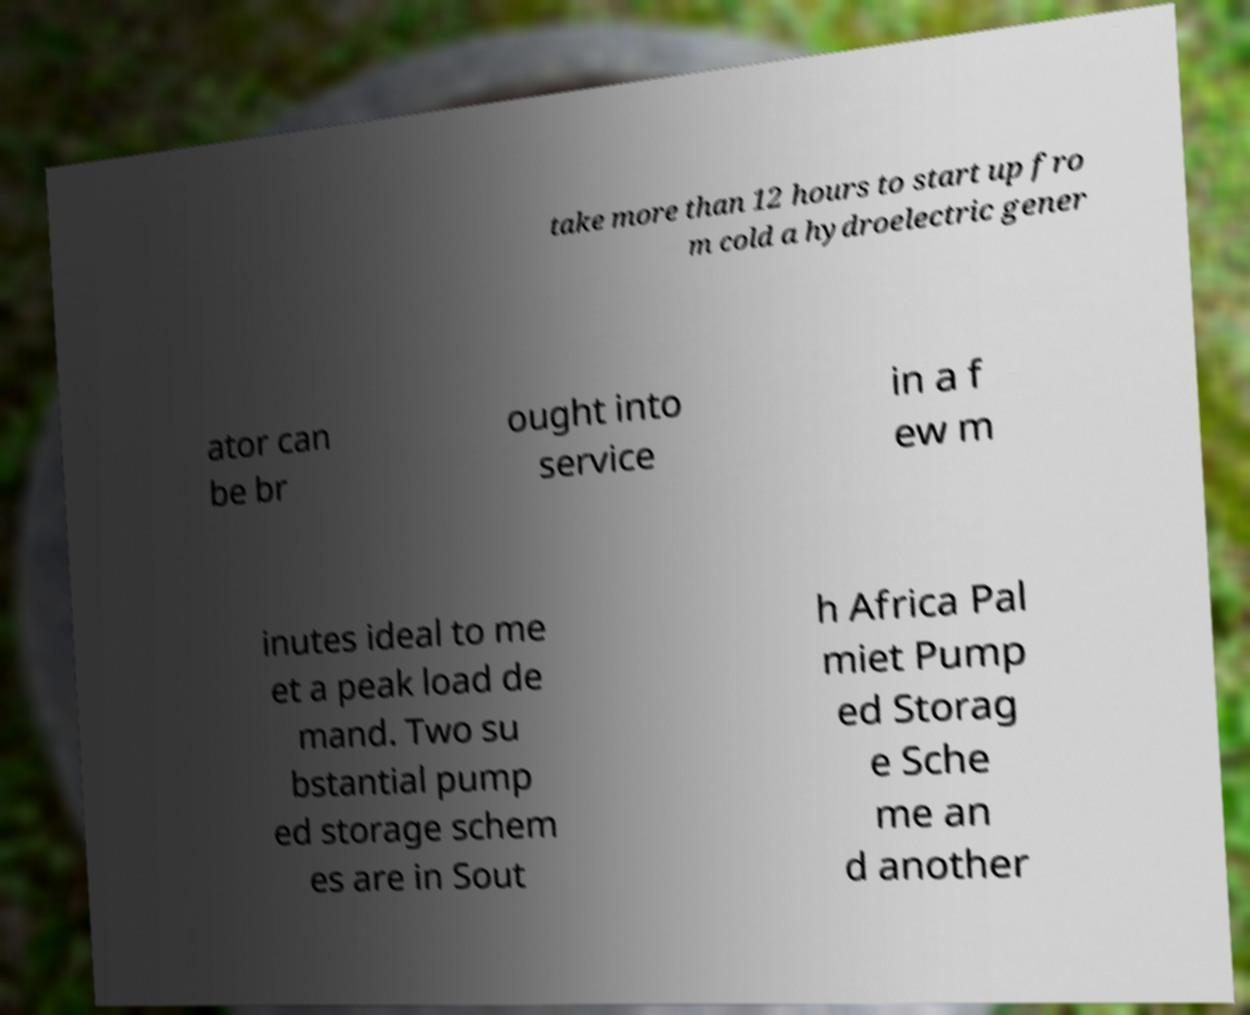Can you accurately transcribe the text from the provided image for me? take more than 12 hours to start up fro m cold a hydroelectric gener ator can be br ought into service in a f ew m inutes ideal to me et a peak load de mand. Two su bstantial pump ed storage schem es are in Sout h Africa Pal miet Pump ed Storag e Sche me an d another 